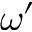<formula> <loc_0><loc_0><loc_500><loc_500>\omega ^ { \prime }</formula> 